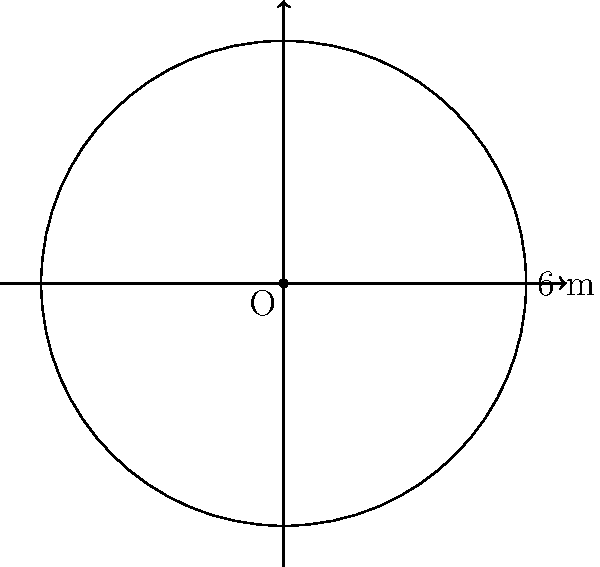As a plant breeder, you're designing a circular garden plot for testing new hybrid varieties. If the diameter of the plot is 6 meters, what is the area of the garden in square meters? Round your answer to two decimal places. To calculate the area of a circular garden plot, we'll follow these steps:

1. Recall the formula for the area of a circle:
   $$A = \pi r^2$$
   where $A$ is the area and $r$ is the radius.

2. We're given the diameter, which is 6 meters. The radius is half of the diameter:
   $$r = \frac{diameter}{2} = \frac{6}{2} = 3 \text{ meters}$$

3. Now, let's substitute the radius into the area formula:
   $$A = \pi (3)^2$$

4. Simplify:
   $$A = \pi \cdot 9 = 9\pi \text{ square meters}$$

5. Calculate the value (using $\pi \approx 3.14159$):
   $$A \approx 9 \cdot 3.14159 = 28.27431 \text{ square meters}$$

6. Rounding to two decimal places:
   $$A \approx 28.27 \text{ square meters}$$
Answer: 28.27 m² 